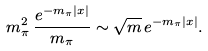Convert formula to latex. <formula><loc_0><loc_0><loc_500><loc_500>m _ { \pi } ^ { 2 } \, \frac { e ^ { - m _ { \pi } | x | } } { m _ { \pi } } \sim \sqrt { m } \, e ^ { - m _ { \pi } | x | } .</formula> 